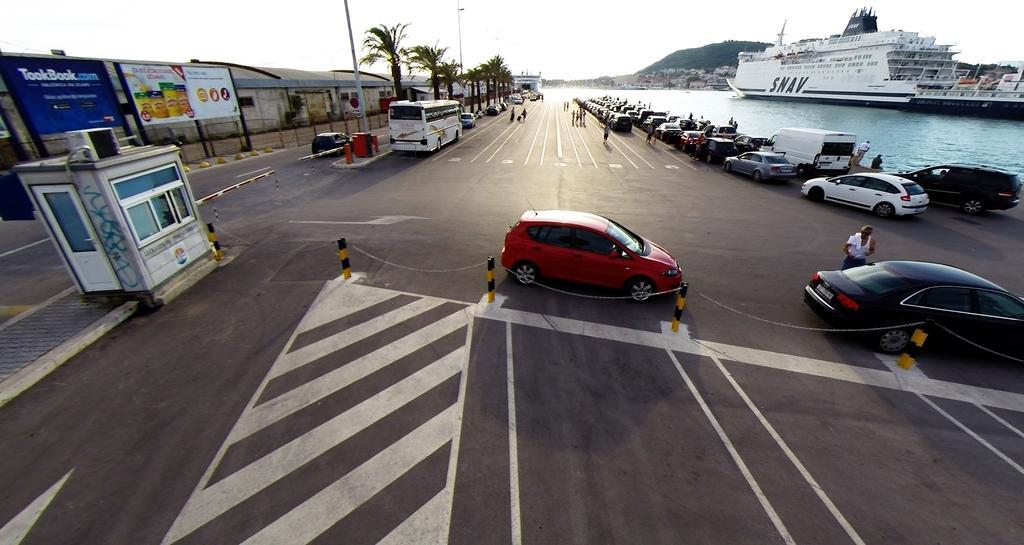In one or two sentences, can you explain what this image depicts? In the image there is a road and on the road there are many vehicles, trees and on the right side there is a water surface, on the water surface there is a ship, in the background there are houses and a mountain. 